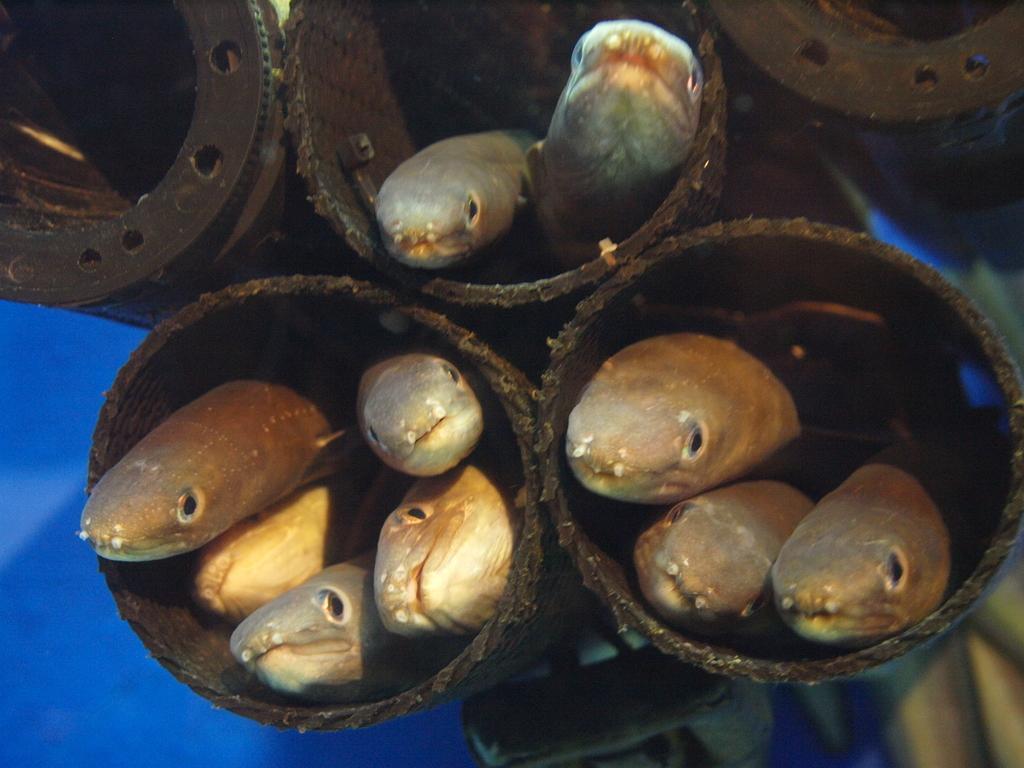In one or two sentences, can you explain what this image depicts? In the image there are some fishes, in the jars. 